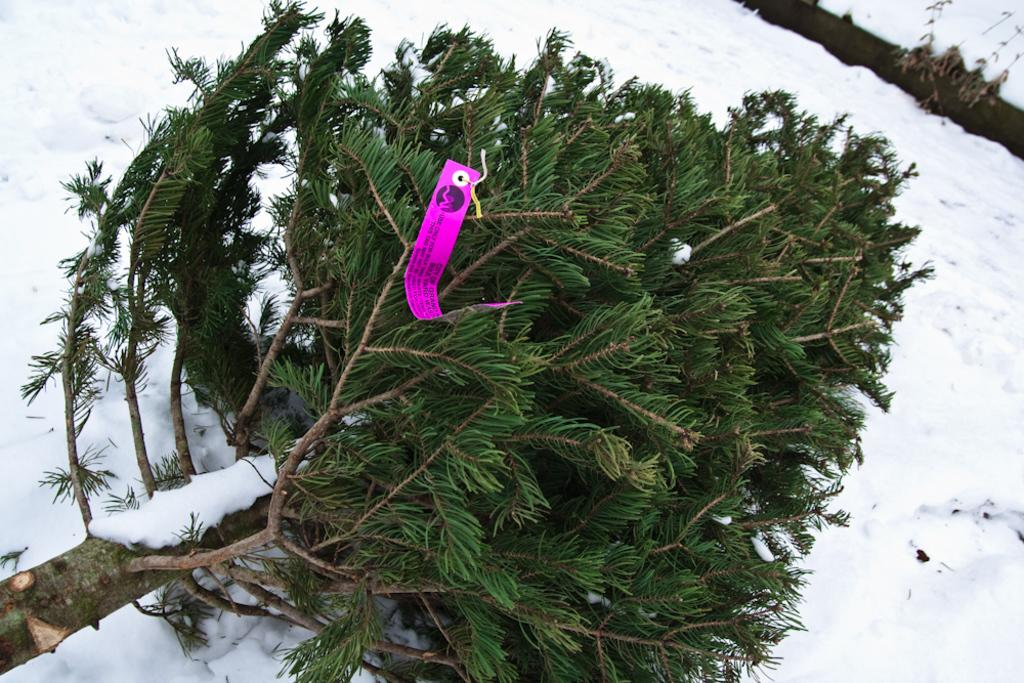What is the main subject of the image? The main subject of the image is a tree fallen on the snow. Is there any additional information about the tree? Yes, there is a tag on the tree. Are there any other objects visible in the image? Yes, there is a log is visible on the snow in the right top corner of the image. What type of hen can be seen in the image? There is no hen present in the image. What historical event is depicted in the image? The image does not depict any historical event or war. 